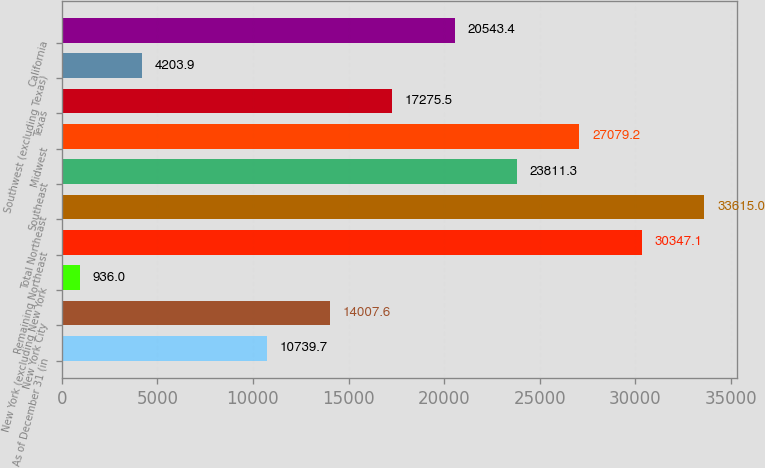<chart> <loc_0><loc_0><loc_500><loc_500><bar_chart><fcel>As of December 31 (in<fcel>New York City<fcel>New York (excluding New York<fcel>Remaining Northeast<fcel>Total Northeast<fcel>Southeast<fcel>Midwest<fcel>Texas<fcel>Southwest (excluding Texas)<fcel>California<nl><fcel>10739.7<fcel>14007.6<fcel>936<fcel>30347.1<fcel>33615<fcel>23811.3<fcel>27079.2<fcel>17275.5<fcel>4203.9<fcel>20543.4<nl></chart> 